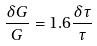Convert formula to latex. <formula><loc_0><loc_0><loc_500><loc_500>\frac { \delta G } { G } = 1 . 6 \frac { \delta \tau } { \tau }</formula> 